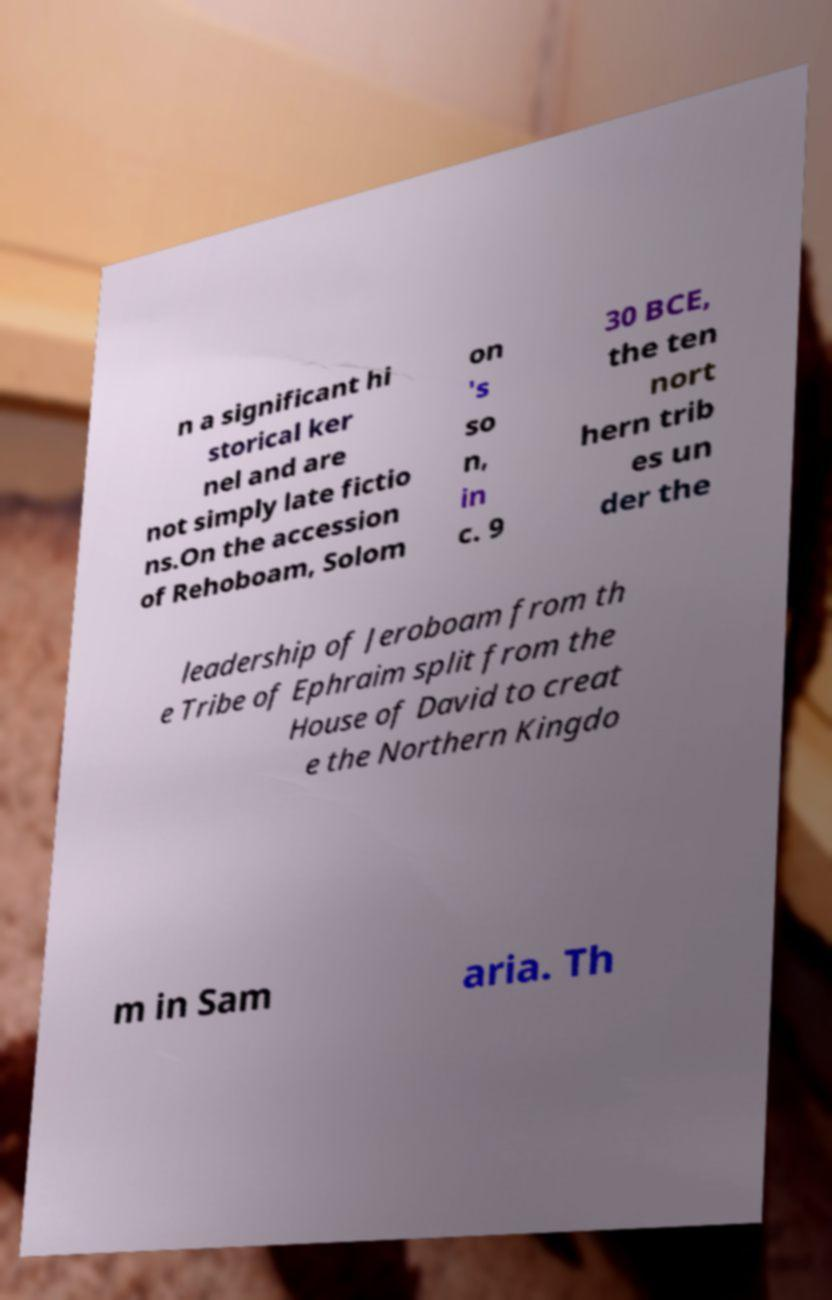What messages or text are displayed in this image? I need them in a readable, typed format. n a significant hi storical ker nel and are not simply late fictio ns.On the accession of Rehoboam, Solom on 's so n, in c. 9 30 BCE, the ten nort hern trib es un der the leadership of Jeroboam from th e Tribe of Ephraim split from the House of David to creat e the Northern Kingdo m in Sam aria. Th 